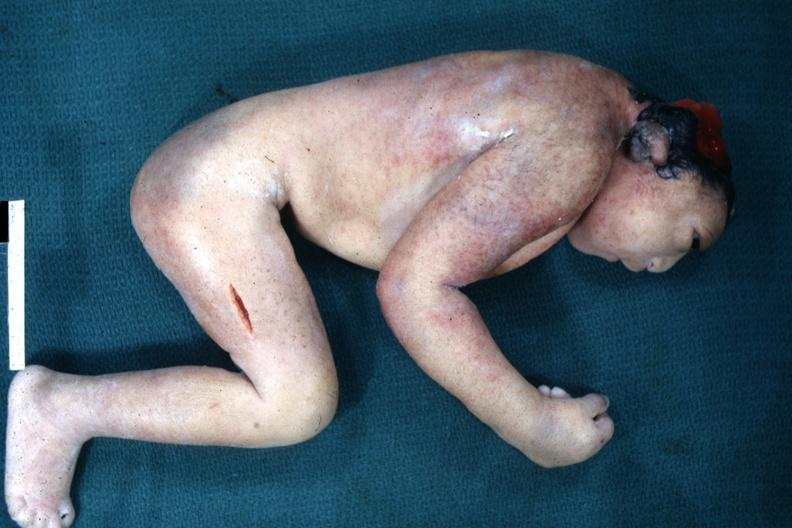s anencephaly present?
Answer the question using a single word or phrase. Yes 